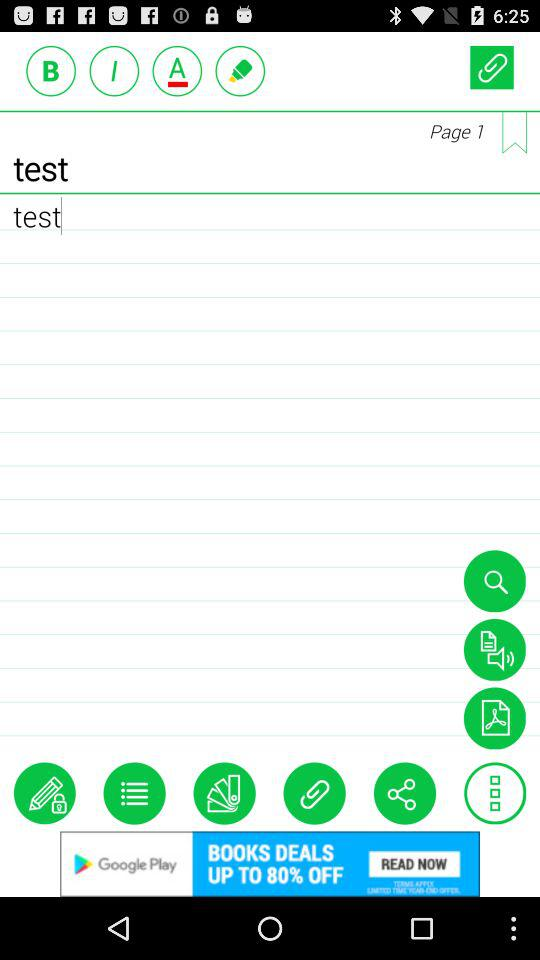Through which apps can the content be shared?
When the provided information is insufficient, respond with <no answer>. <no answer> 